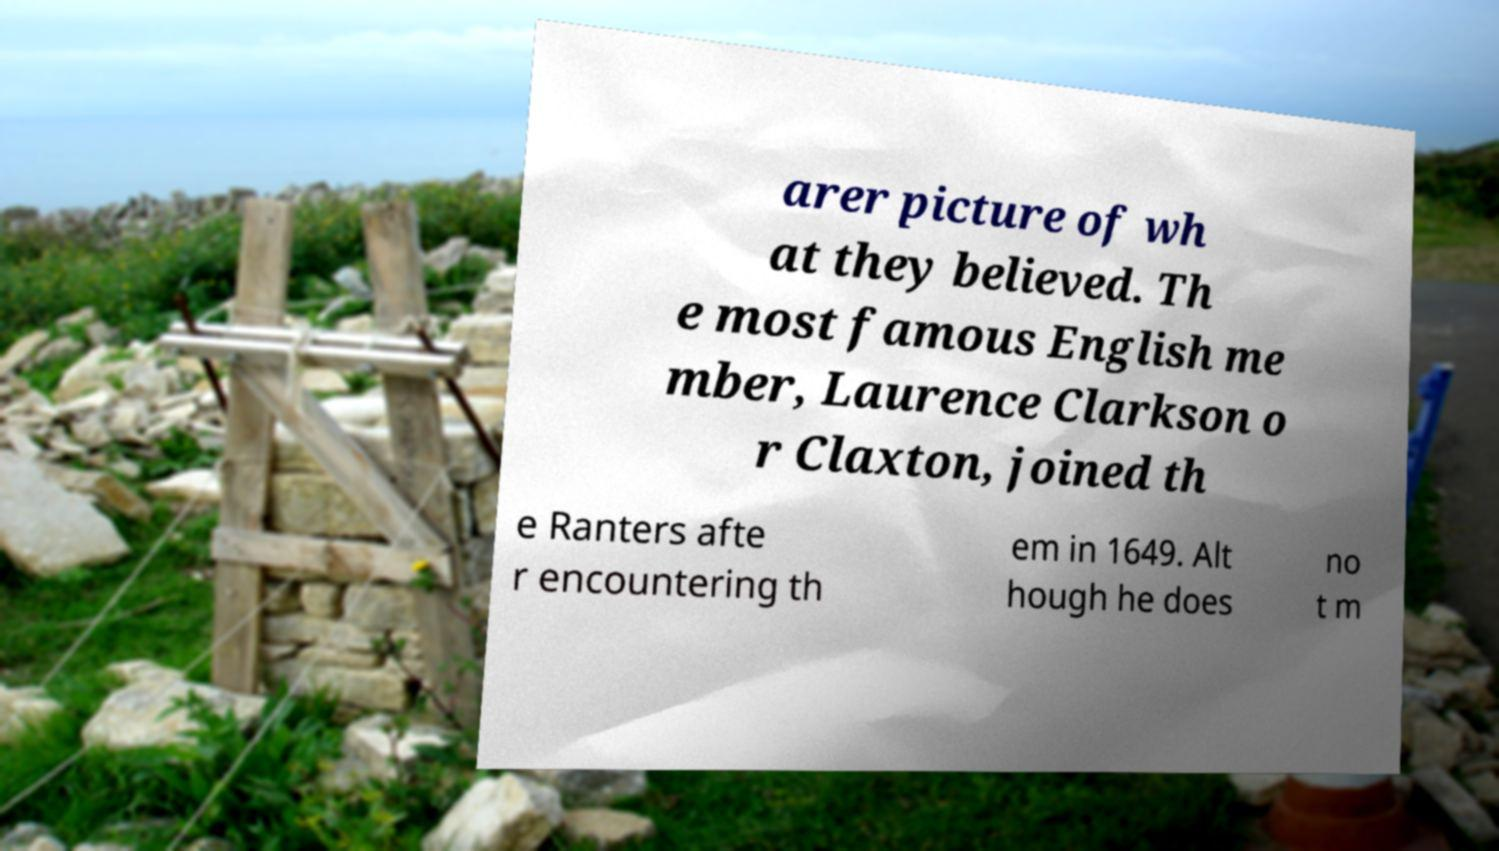Can you read and provide the text displayed in the image?This photo seems to have some interesting text. Can you extract and type it out for me? arer picture of wh at they believed. Th e most famous English me mber, Laurence Clarkson o r Claxton, joined th e Ranters afte r encountering th em in 1649. Alt hough he does no t m 